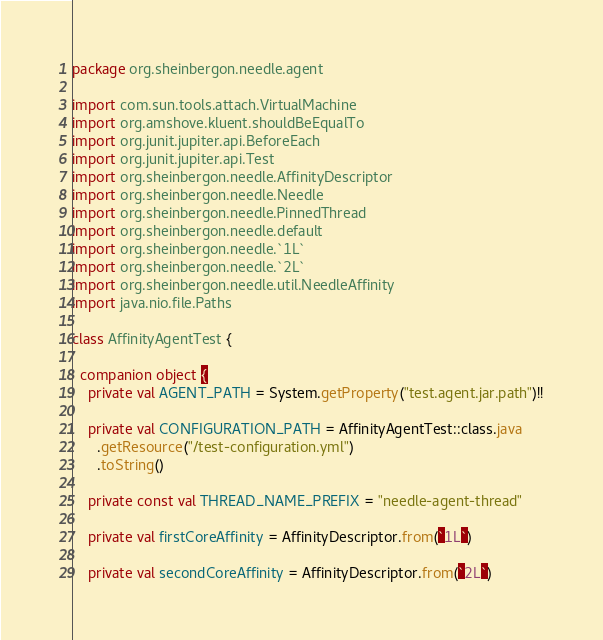Convert code to text. <code><loc_0><loc_0><loc_500><loc_500><_Kotlin_>package org.sheinbergon.needle.agent

import com.sun.tools.attach.VirtualMachine
import org.amshove.kluent.shouldBeEqualTo
import org.junit.jupiter.api.BeforeEach
import org.junit.jupiter.api.Test
import org.sheinbergon.needle.AffinityDescriptor
import org.sheinbergon.needle.Needle
import org.sheinbergon.needle.PinnedThread
import org.sheinbergon.needle.default
import org.sheinbergon.needle.`1L`
import org.sheinbergon.needle.`2L`
import org.sheinbergon.needle.util.NeedleAffinity
import java.nio.file.Paths

class AffinityAgentTest {

  companion object {
    private val AGENT_PATH = System.getProperty("test.agent.jar.path")!!

    private val CONFIGURATION_PATH = AffinityAgentTest::class.java
      .getResource("/test-configuration.yml")
      .toString()

    private const val THREAD_NAME_PREFIX = "needle-agent-thread"

    private val firstCoreAffinity = AffinityDescriptor.from(`1L`)

    private val secondCoreAffinity = AffinityDescriptor.from(`2L`)
</code> 